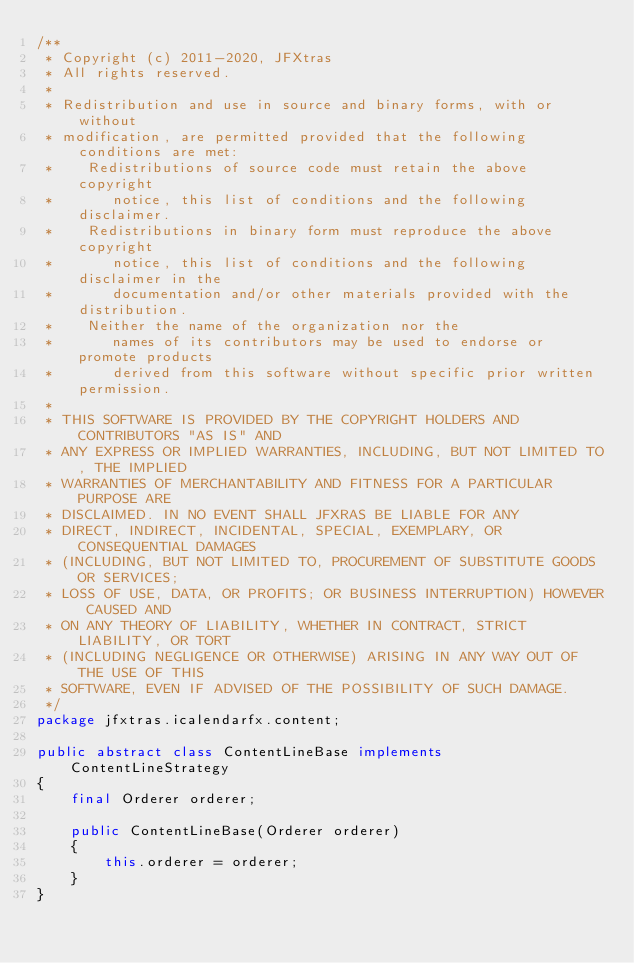Convert code to text. <code><loc_0><loc_0><loc_500><loc_500><_Java_>/**
 * Copyright (c) 2011-2020, JFXtras
 * All rights reserved.
 *
 * Redistribution and use in source and binary forms, with or without
 * modification, are permitted provided that the following conditions are met:
 *    Redistributions of source code must retain the above copyright
 *       notice, this list of conditions and the following disclaimer.
 *    Redistributions in binary form must reproduce the above copyright
 *       notice, this list of conditions and the following disclaimer in the
 *       documentation and/or other materials provided with the distribution.
 *    Neither the name of the organization nor the
 *       names of its contributors may be used to endorse or promote products
 *       derived from this software without specific prior written permission.
 *
 * THIS SOFTWARE IS PROVIDED BY THE COPYRIGHT HOLDERS AND CONTRIBUTORS "AS IS" AND
 * ANY EXPRESS OR IMPLIED WARRANTIES, INCLUDING, BUT NOT LIMITED TO, THE IMPLIED
 * WARRANTIES OF MERCHANTABILITY AND FITNESS FOR A PARTICULAR PURPOSE ARE
 * DISCLAIMED. IN NO EVENT SHALL JFXRAS BE LIABLE FOR ANY
 * DIRECT, INDIRECT, INCIDENTAL, SPECIAL, EXEMPLARY, OR CONSEQUENTIAL DAMAGES
 * (INCLUDING, BUT NOT LIMITED TO, PROCUREMENT OF SUBSTITUTE GOODS OR SERVICES;
 * LOSS OF USE, DATA, OR PROFITS; OR BUSINESS INTERRUPTION) HOWEVER CAUSED AND
 * ON ANY THEORY OF LIABILITY, WHETHER IN CONTRACT, STRICT LIABILITY, OR TORT
 * (INCLUDING NEGLIGENCE OR OTHERWISE) ARISING IN ANY WAY OUT OF THE USE OF THIS
 * SOFTWARE, EVEN IF ADVISED OF THE POSSIBILITY OF SUCH DAMAGE.
 */
package jfxtras.icalendarfx.content;

public abstract class ContentLineBase implements ContentLineStrategy
{
    final Orderer orderer;
    
    public ContentLineBase(Orderer orderer)
    {
        this.orderer = orderer;
    }
}
</code> 